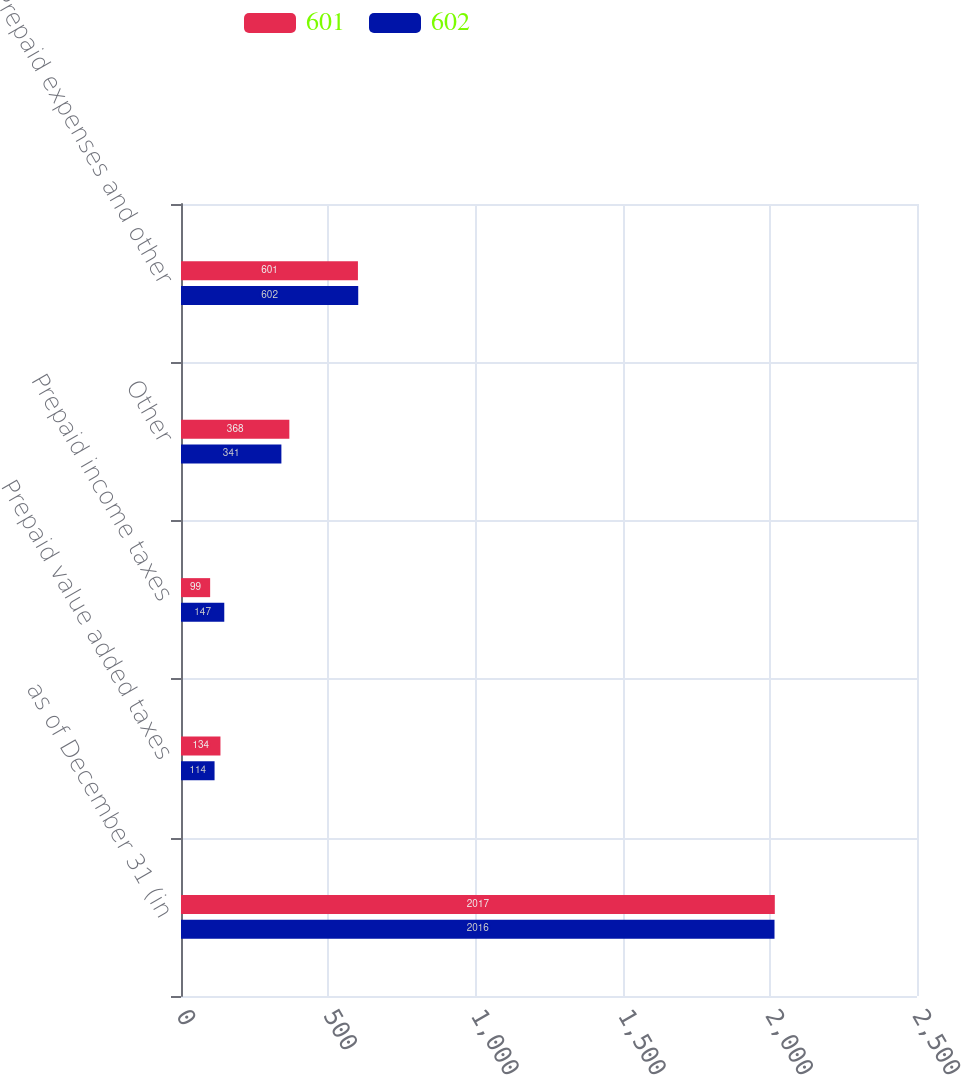<chart> <loc_0><loc_0><loc_500><loc_500><stacked_bar_chart><ecel><fcel>as of December 31 (in<fcel>Prepaid value added taxes<fcel>Prepaid income taxes<fcel>Other<fcel>Prepaid expenses and other<nl><fcel>601<fcel>2017<fcel>134<fcel>99<fcel>368<fcel>601<nl><fcel>602<fcel>2016<fcel>114<fcel>147<fcel>341<fcel>602<nl></chart> 